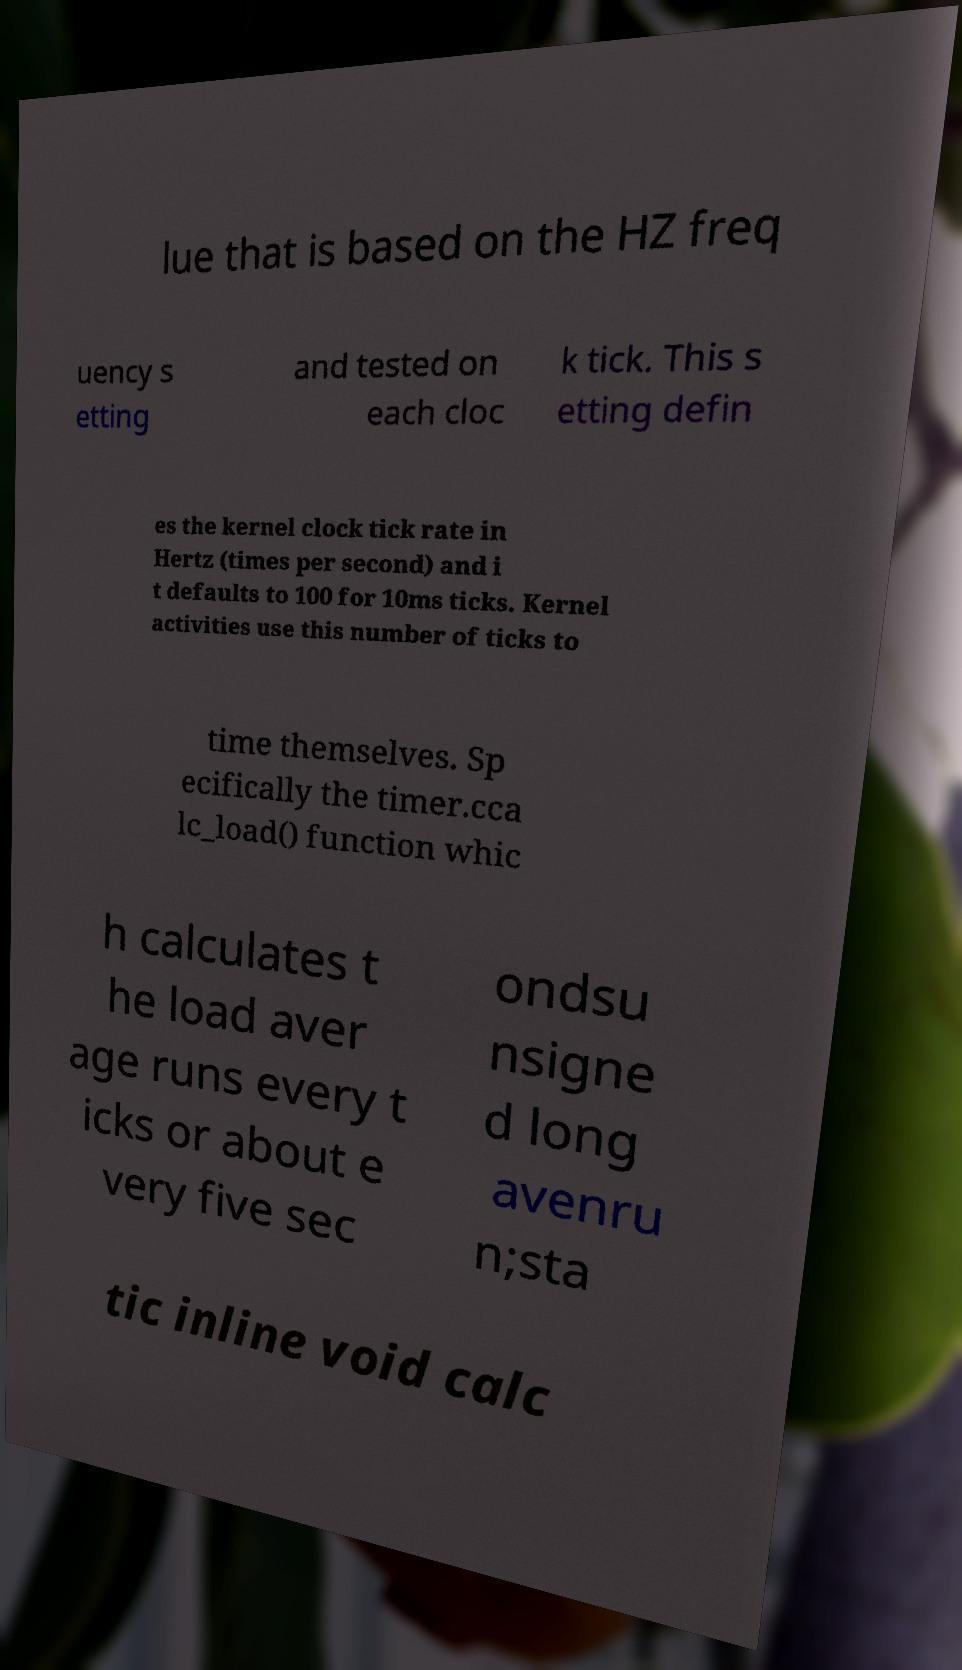Can you read and provide the text displayed in the image?This photo seems to have some interesting text. Can you extract and type it out for me? lue that is based on the HZ freq uency s etting and tested on each cloc k tick. This s etting defin es the kernel clock tick rate in Hertz (times per second) and i t defaults to 100 for 10ms ticks. Kernel activities use this number of ticks to time themselves. Sp ecifically the timer.cca lc_load() function whic h calculates t he load aver age runs every t icks or about e very five sec ondsu nsigne d long avenru n;sta tic inline void calc 